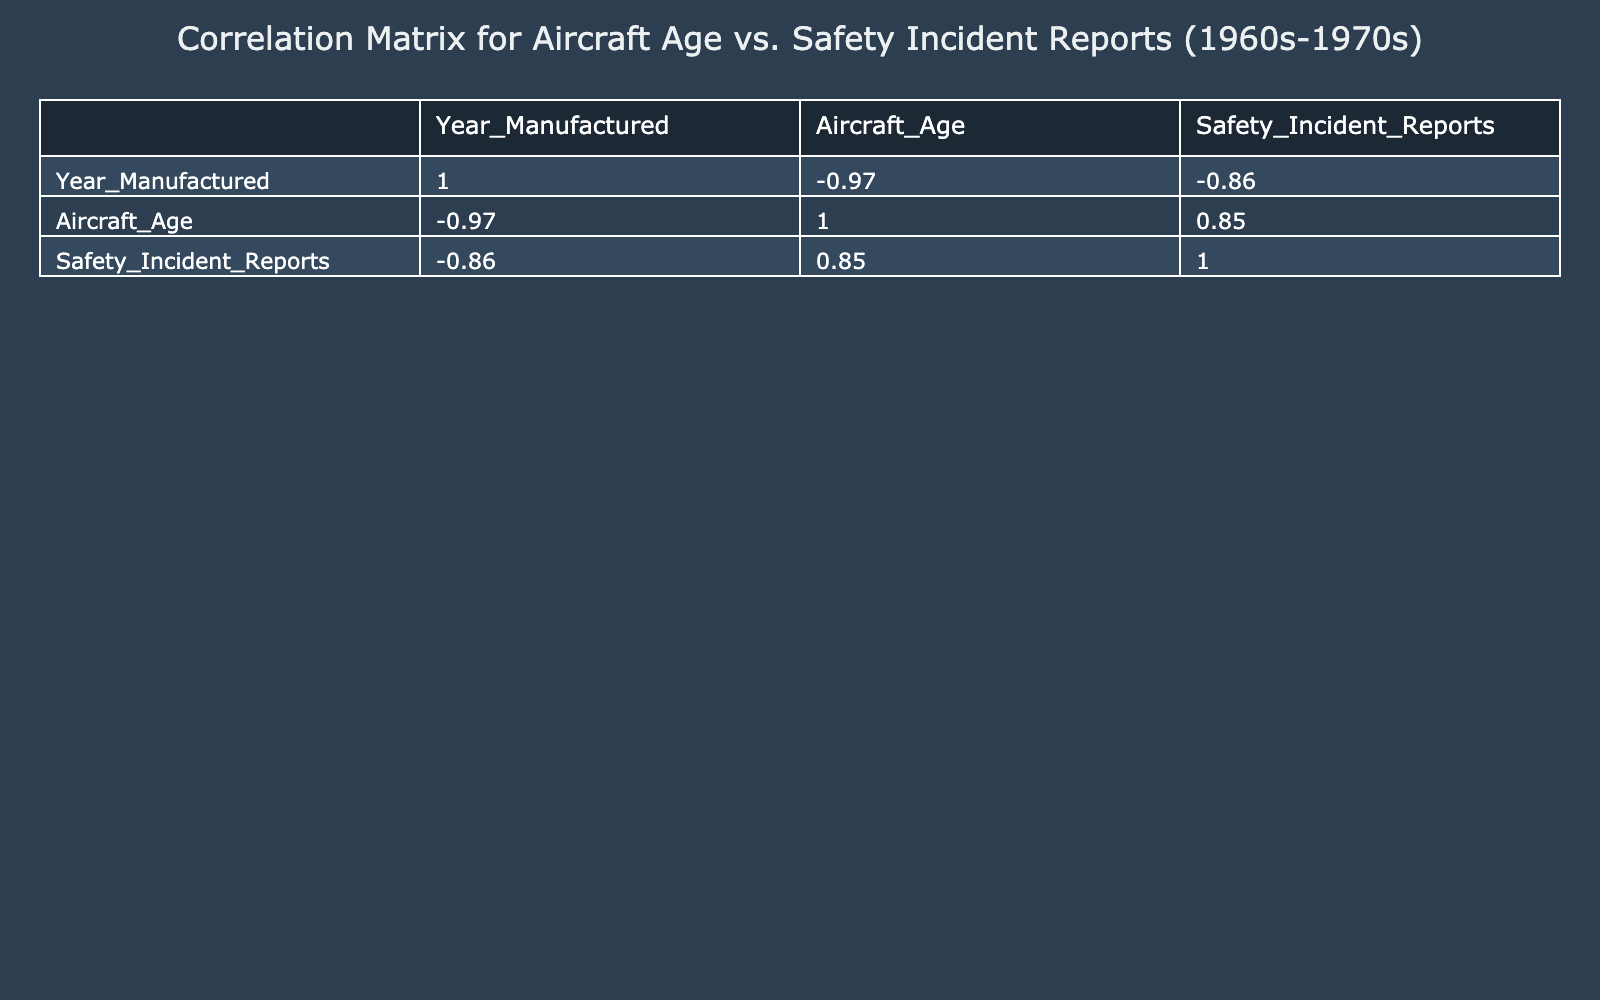What is the safety incident report count for the Boeing 707? The Boeing 707 shows a safety incident report count of 15 in the table. This value can be found directly by locating the row for the Boeing 707 and reading the corresponding safety incident report count.
Answer: 15 Which aircraft has the highest safety incident reports? The Boeing 707 has the highest safety incident reports with a count of 15 among all listed aircraft. By comparing the values in the Safety Incident Reports column, it is clear that 15 is the maximum.
Answer: Boeing 707 What is the average safety incident reports for aircraft older than 5 years? The relevant aircraft older than 5 years are the Boeing 707 (15), Convair 880 (8), and Lockheed Constellation (14). The average is calculated by summing these reports (15 + 8 + 14 = 37) and dividing by the three aircraft (37/3 = 12.33). Thus, the average safety incident report for these older aircraft is approximately 12.33.
Answer: 12.33 Is there a direct correlation between aircraft age and the number of safety incident reports? To determine if a correlation exists, one can observe the trend by looking at aircraft age and their corresponding incident reports. As the aircraft age increases, the incident reports generally appear to rise until reaching a peak with the older models. This suggests that there is a trend that suggests yes, there is a form of correlation.
Answer: Yes What is the difference in safety incident reports between the oldest and the newest aircraft? The oldest aircraft is the Boeing 707 with 15 incident reports, and the newest is the Airbus A300 with 2 incident reports. The difference can be calculated by subtracting the latter from the former (15 - 2 = 13), which shows that there is a difference of 13 safety incident reports.
Answer: 13 Which two aircraft have the same age but different safety incident report counts? The McDonnell Douglas DC-8 and Douglas DC-9 both have an aircraft age of 5 years; however, they report different counts of safety incidents: 9 for the DC-8 and 7 for the DC-9. This can be verified by checking the rows for both aircraft.
Answer: McDonnell Douglas DC-8 and Douglas DC-9 How many aircraft models have a safety incident report count of 4 or fewer? Looking through the table, the aircraft models with 4 or fewer reports are the Boeing 737-100 (3 reports), Lockheed L-1011 (1 report), and Airbus A300 (2 reports). Counting these confirms there are 3 such aircraft models.
Answer: 3 Is the Boeing 727 more prone to incidents than the Lockheed L-1011? The Boeing 727 has 12 safety incident reports, while the Lockheed L-1011 has just 1. Given that the Boeing 727 has significantly more incident reports, it indicates that yes, the Boeing 727 is indeed more prone to incidents compared to the Lockheed L-1011.
Answer: Yes What is the median number of safety incident reports? To find the median, we first list the safety incident report counts in order: 1, 2, 3, 4, 7, 8, 9, 12, 14, 15. With 10 data points, the median will be the average of the 5th and 6th numbers (7 and 8). Calculating this gives (7 + 8) / 2 = 7.5. Hence, the median number of safety incident reports is 7.5.
Answer: 7.5 